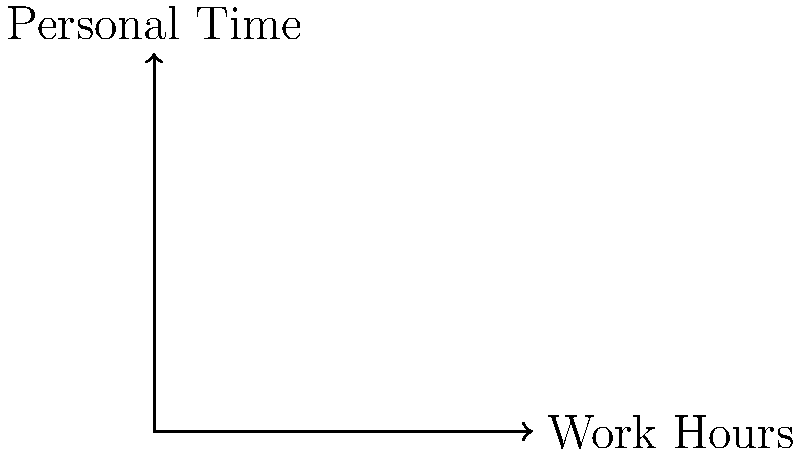In the context of work-life balance, point A(2,8) represents an individual working 2 hours and having 8 hours of personal time, while point B(8,2) represents working 8 hours with only 2 hours of personal time. Find the coordinates of point M, which represents the midpoint between these two extremes. How might this midpoint relate to a more balanced lifestyle? To find the midpoint M between two points A(x₁, y₁) and B(x₂, y₂), we use the midpoint formula:

$$ M = (\frac{x_1 + x_2}{2}, \frac{y_1 + y_2}{2}) $$

For our given points:
A(2,8) and B(8,2)

Step 1: Calculate the x-coordinate of the midpoint:
$$ x_M = \frac{x_1 + x_2}{2} = \frac{2 + 8}{2} = \frac{10}{2} = 5 $$

Step 2: Calculate the y-coordinate of the midpoint:
$$ y_M = \frac{y_1 + y_2}{2} = \frac{8 + 2}{2} = \frac{10}{2} = 5 $$

Therefore, the midpoint M has coordinates (5,5).

In the context of work-life balance, this midpoint represents an equal distribution of time between work (5 hours) and personal activities (5 hours). This balanced allocation of time might be considered a more sustainable and healthy lifestyle compared to the extremes represented by points A and B.

For a clinical psychologist, this midpoint could be used to discuss with clients the importance of finding a balance between professional responsibilities and personal well-being, potentially leading to reduced stress and improved overall life satisfaction.
Answer: M(5,5) 